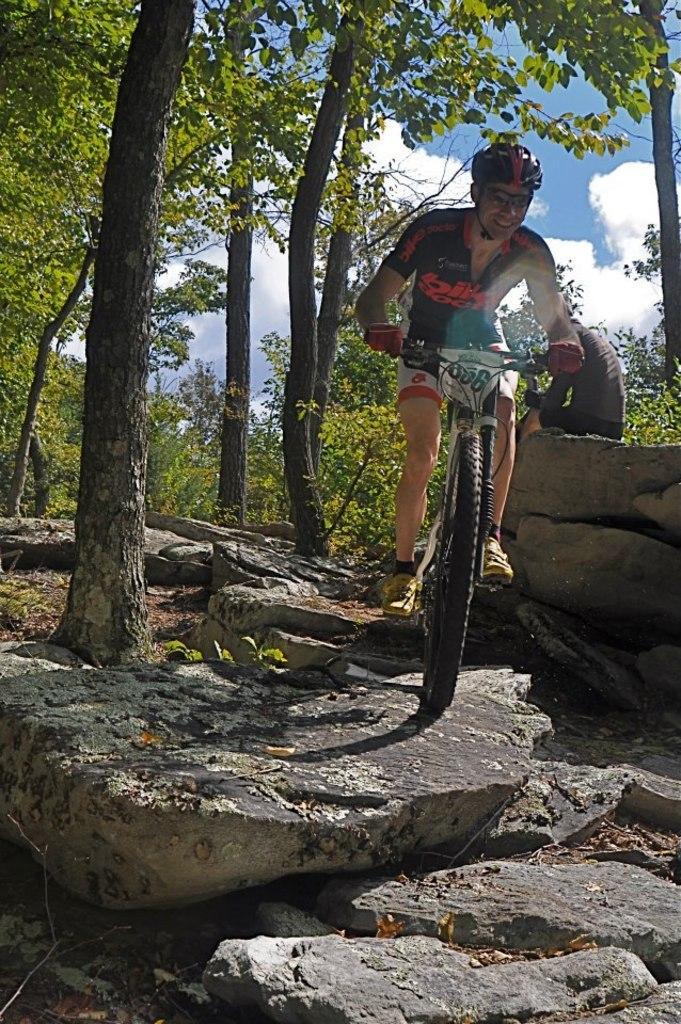Can you describe this image briefly? In this picture I can see a person riding a bicycle, there is a person sitting on the rock, there are rocks, trees, and in the background there is sky. 